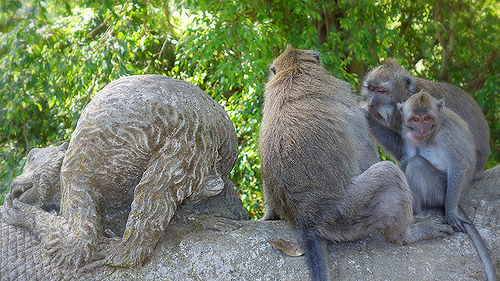<image>
Is there a monkey on the statue? No. The monkey is not positioned on the statue. They may be near each other, but the monkey is not supported by or resting on top of the statue. Is there a patrick in the branch? Yes. The patrick is contained within or inside the branch, showing a containment relationship. 